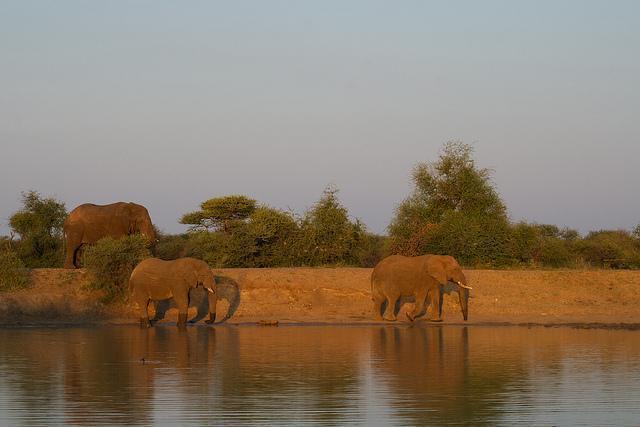What direction are the elephants facing?
Indicate the correct response and explain using: 'Answer: answer
Rationale: rationale.'
Options: Down, right, left, up. Answer: right.
Rationale: The elephants seems to be looking right from the river. 